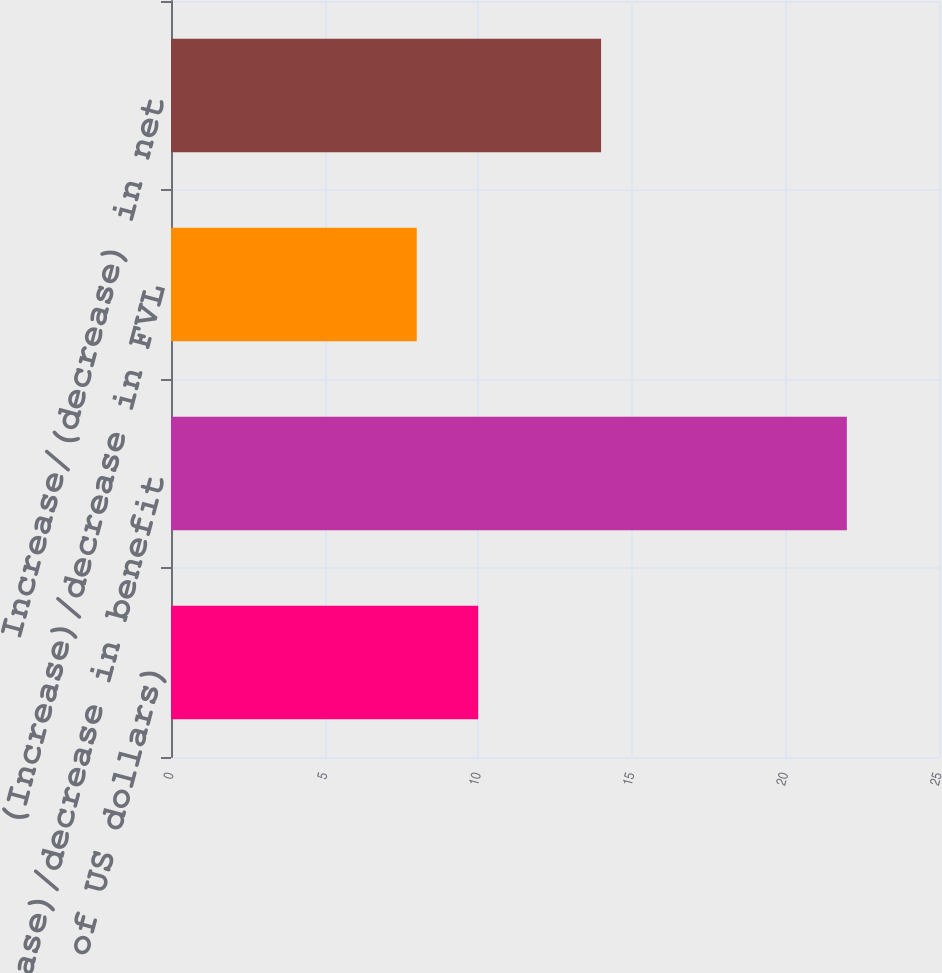<chart> <loc_0><loc_0><loc_500><loc_500><bar_chart><fcel>(in millions of US dollars)<fcel>(Increase)/decrease in benefit<fcel>(Increase)/decrease in FVL<fcel>Increase/(decrease) in net<nl><fcel>10<fcel>22<fcel>8<fcel>14<nl></chart> 